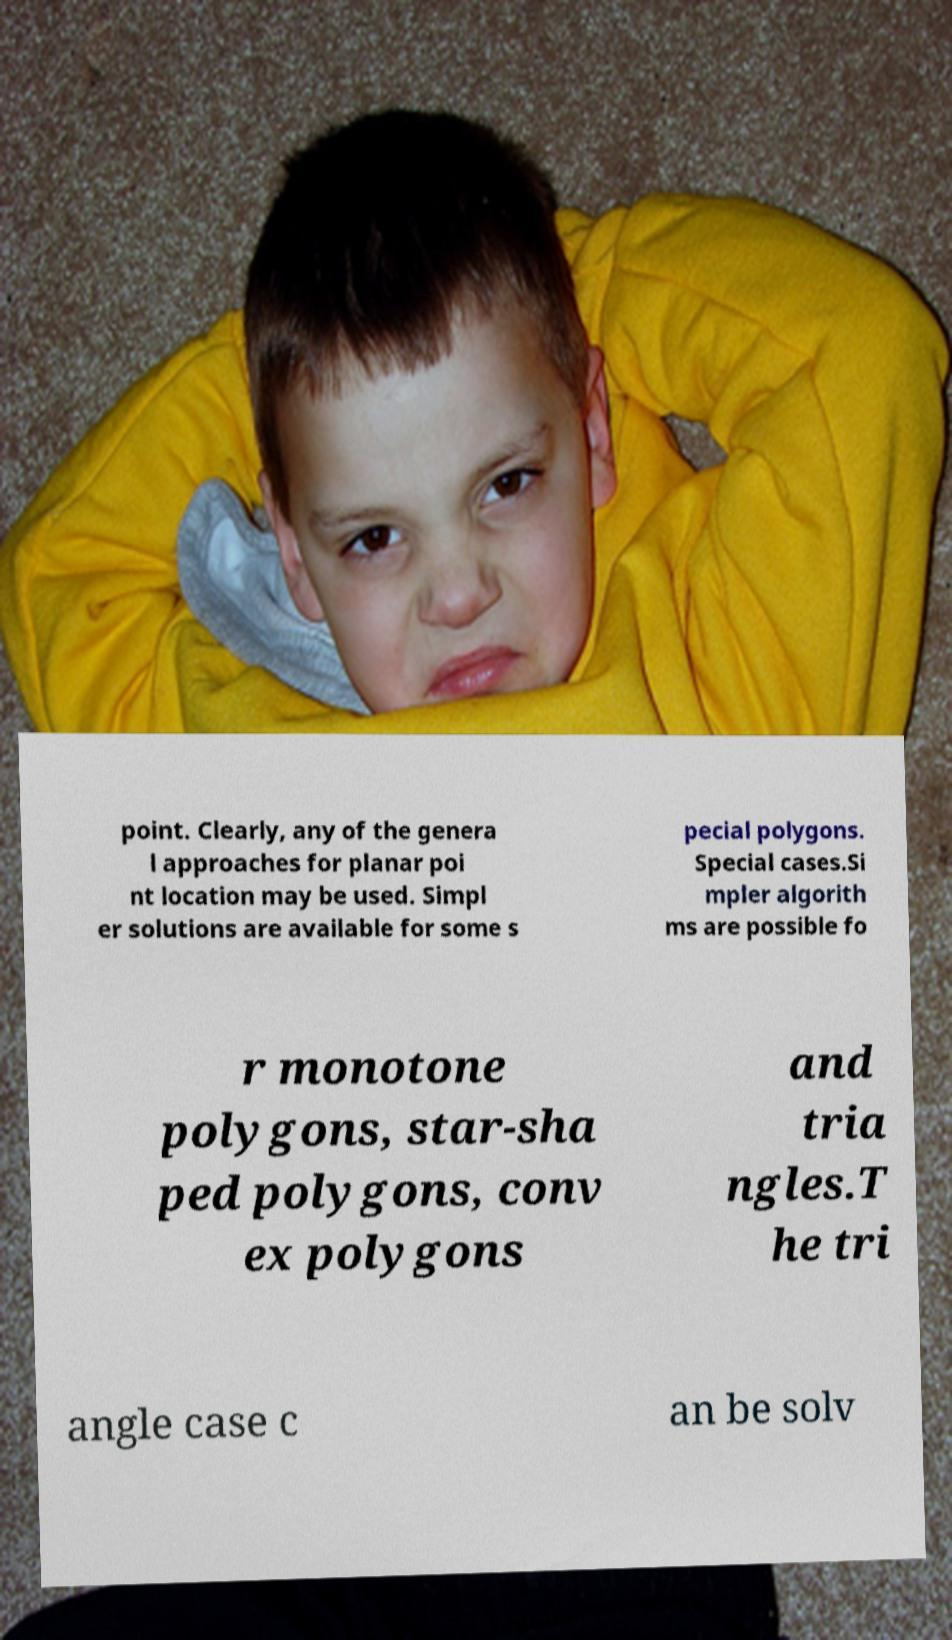Can you read and provide the text displayed in the image?This photo seems to have some interesting text. Can you extract and type it out for me? point. Clearly, any of the genera l approaches for planar poi nt location may be used. Simpl er solutions are available for some s pecial polygons. Special cases.Si mpler algorith ms are possible fo r monotone polygons, star-sha ped polygons, conv ex polygons and tria ngles.T he tri angle case c an be solv 